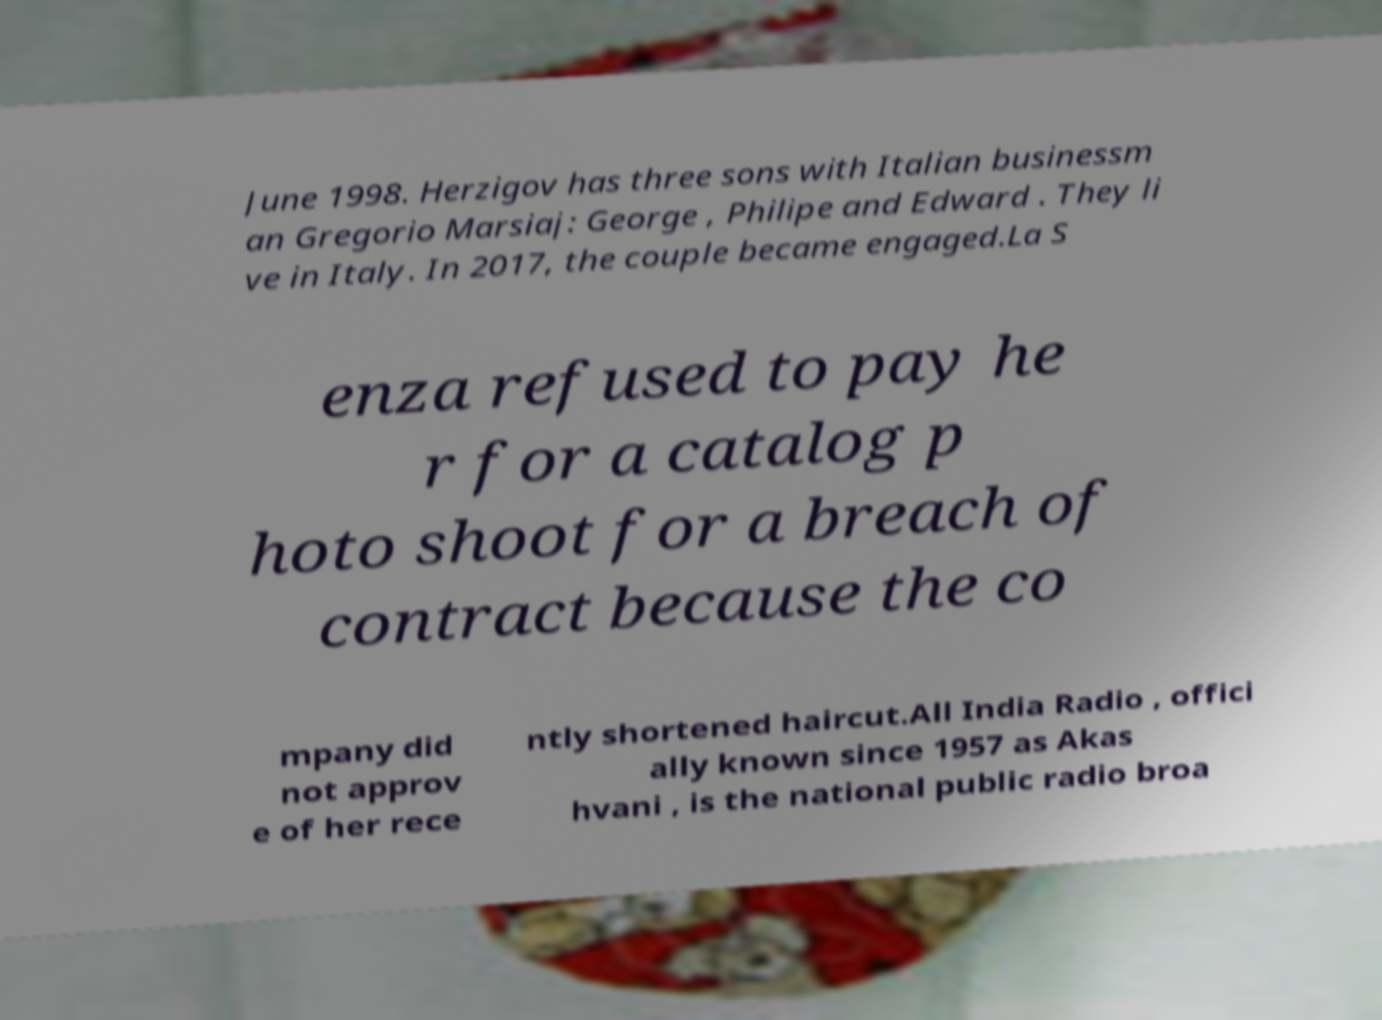Please identify and transcribe the text found in this image. June 1998. Herzigov has three sons with Italian businessm an Gregorio Marsiaj: George , Philipe and Edward . They li ve in Italy. In 2017, the couple became engaged.La S enza refused to pay he r for a catalog p hoto shoot for a breach of contract because the co mpany did not approv e of her rece ntly shortened haircut.All India Radio , offici ally known since 1957 as Akas hvani , is the national public radio broa 